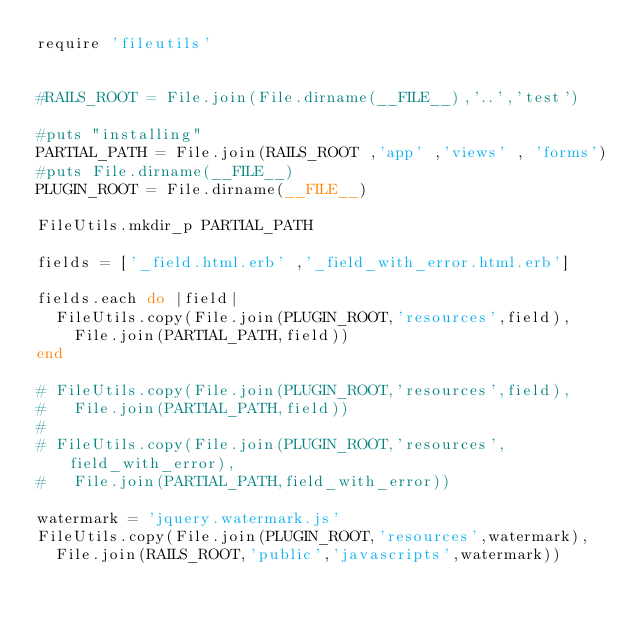<code> <loc_0><loc_0><loc_500><loc_500><_Ruby_>require 'fileutils'


#RAILS_ROOT = File.join(File.dirname(__FILE__),'..','test')

#puts "installing"
PARTIAL_PATH = File.join(RAILS_ROOT ,'app' ,'views' , 'forms')
#puts File.dirname(__FILE__)
PLUGIN_ROOT = File.dirname(__FILE__)

FileUtils.mkdir_p PARTIAL_PATH

fields = ['_field.html.erb' ,'_field_with_error.html.erb']

fields.each do |field|
  FileUtils.copy(File.join(PLUGIN_ROOT,'resources',field),
    File.join(PARTIAL_PATH,field))
end

# FileUtils.copy(File.join(PLUGIN_ROOT,'resources',field),
#   File.join(PARTIAL_PATH,field))
# 
# FileUtils.copy(File.join(PLUGIN_ROOT,'resources',field_with_error),
#   File.join(PARTIAL_PATH,field_with_error))

watermark = 'jquery.watermark.js'
FileUtils.copy(File.join(PLUGIN_ROOT,'resources',watermark),
  File.join(RAILS_ROOT,'public','javascripts',watermark))
</code> 